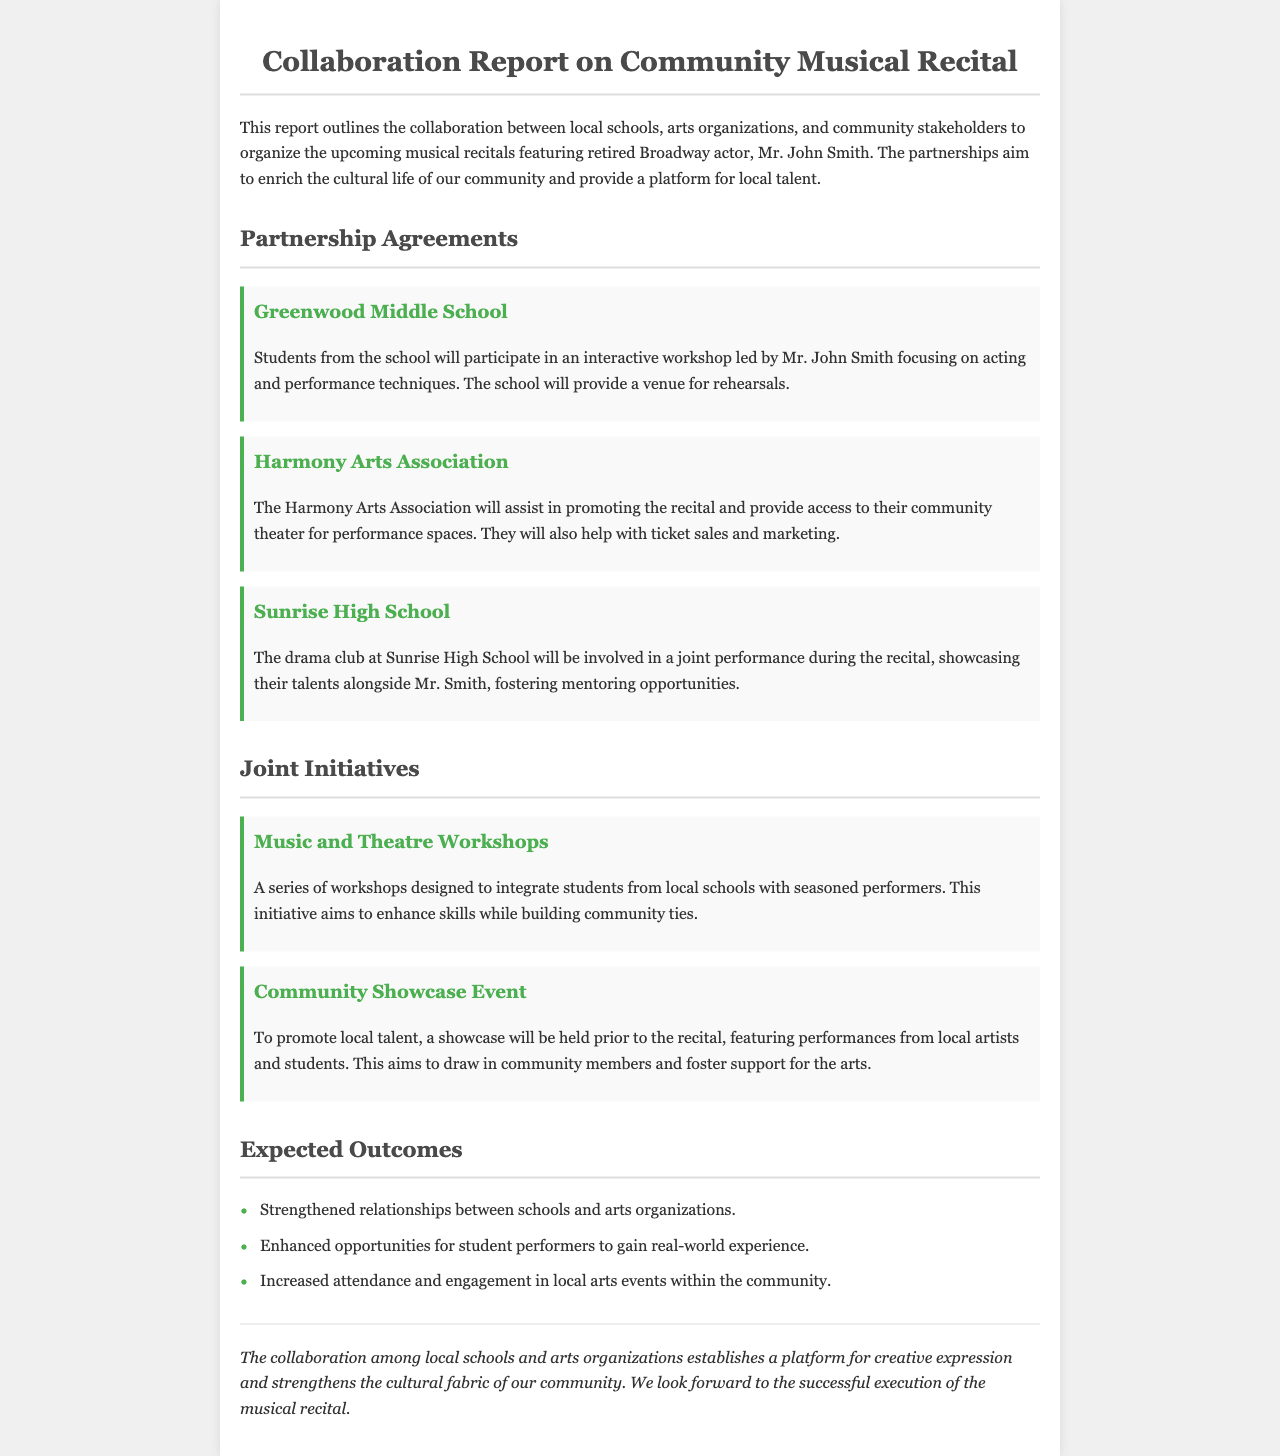what is the name of the retired Broadway actor featured in the recital? The document specifically names the retired Broadway actor as Mr. John Smith.
Answer: Mr. John Smith which school provides a venue for rehearsals? The document states that Greenwood Middle School will provide a venue for rehearsals.
Answer: Greenwood Middle School who will assist in promoting the recital? The document mentions that the Harmony Arts Association will assist in promoting the recital.
Answer: Harmony Arts Association what type of workshops are being organized? The document describes a series of workshops designed to integrate students from local schools with seasoned performers.
Answer: Music and Theatre Workshops what is one expected outcome of the collaboration? The document lists strengthened relationships between schools and arts organizations as an expected outcome.
Answer: Strengthened relationships which initiative aims to showcase local talent? The document indicates that a showcase will be held prior to the recital to promote local talent.
Answer: Community Showcase Event how many schools are mentioned as partners in the collaboration? The document lists three schools that are partners in the collaboration.
Answer: Three what do the workshops aim to enhance? The document states that the workshops aim to enhance skills while building community ties.
Answer: Skills what is the main goal of the collaboration according to the conclusion? The conclusion refers to establishing a platform for creative expression as the main goal.
Answer: Creative expression 